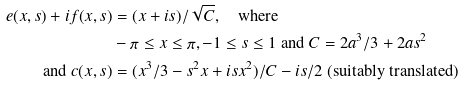<formula> <loc_0><loc_0><loc_500><loc_500>e ( x , s ) + i f ( x , s ) & = ( x + i s ) / \sqrt { C } , \quad \text {where } \\ & - \pi \leq x \leq \pi , - 1 \leq s \leq 1 \text { and } C = 2 a ^ { 3 } / 3 + 2 a s ^ { 2 } \\ \text {and } c ( x , s ) & = ( x ^ { 3 } / 3 - s ^ { 2 } x + i s x ^ { 2 } ) / C - i s / 2 \text { (suitably translated)}</formula> 